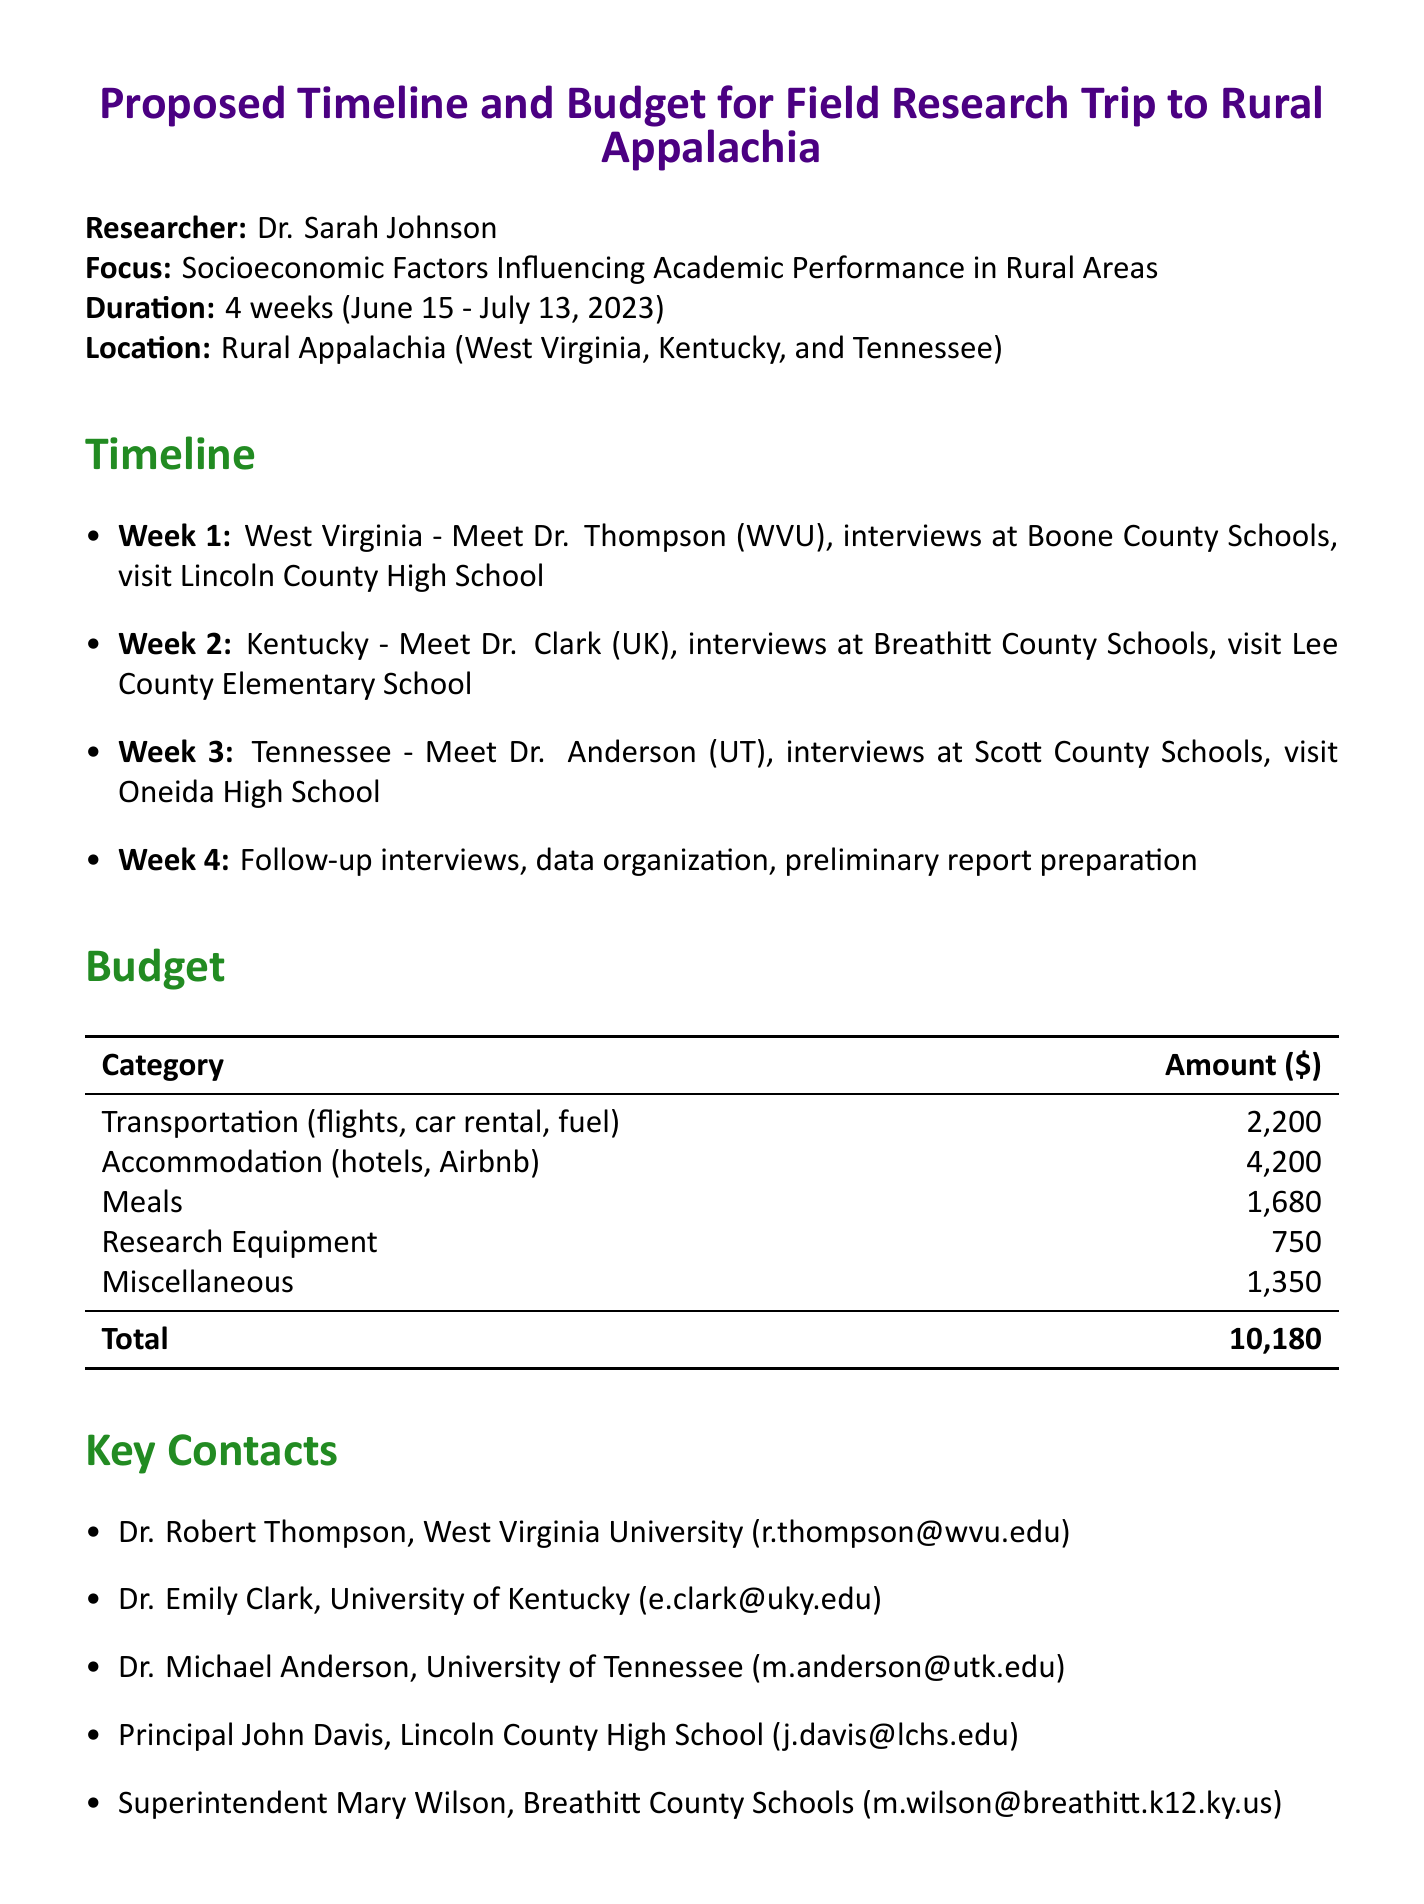what is the research focus? The research focus is the central theme or subject of the study outlined in the memo.
Answer: Socioeconomic Factors Influencing Academic Performance in Rural Areas who is the researcher? The researcher is the individual conducting the study, as listed at the beginning of the memo.
Answer: Dr. Sarah Johnson what are the trip dates? The trip dates detail the specific time frame for the research trip mentioned in the memo.
Answer: June 15 - July 13, 2023 how many rural educators will be interviewed? The total number of rural educators to be interviewed highlights the scale of the research effort.
Answer: 30 what is the total budget for the trip? The total budget summarizes the overall financial expenditure planned for the field research trip.
Answer: 10180 which location is the focus of the research trip? The location indicates the geographic area where the research activities will take place.
Answer: Rural Appalachia what is one expected outcome of the research? The expected outcome describes the anticipated results or goals of the research project.
Answer: Comprehensive dataset on rural education challenges who will the researcher meet in Week 1? This question addresses the specific contact or collaboration occurring in the first week of the trip.
Answer: Dr. Robert Thompson what type of research equipment is included in the budget? This refers to the specific tools or technology planned for use during the research, as mentioned in the budget section.
Answer: audio recorder 